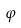Convert formula to latex. <formula><loc_0><loc_0><loc_500><loc_500>\varphi</formula> 